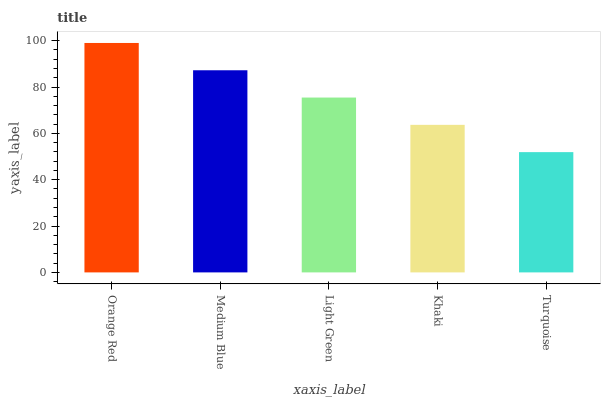Is Medium Blue the minimum?
Answer yes or no. No. Is Medium Blue the maximum?
Answer yes or no. No. Is Orange Red greater than Medium Blue?
Answer yes or no. Yes. Is Medium Blue less than Orange Red?
Answer yes or no. Yes. Is Medium Blue greater than Orange Red?
Answer yes or no. No. Is Orange Red less than Medium Blue?
Answer yes or no. No. Is Light Green the high median?
Answer yes or no. Yes. Is Light Green the low median?
Answer yes or no. Yes. Is Turquoise the high median?
Answer yes or no. No. Is Turquoise the low median?
Answer yes or no. No. 